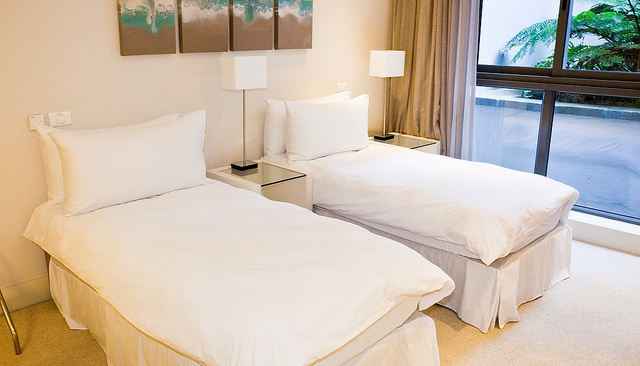Describe the objects in this image and their specific colors. I can see bed in tan and lightgray tones and bed in tan, lightgray, and darkgray tones in this image. 